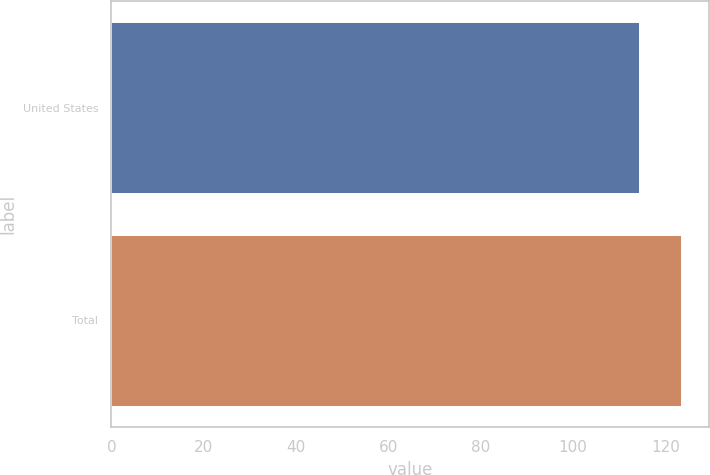Convert chart. <chart><loc_0><loc_0><loc_500><loc_500><bar_chart><fcel>United States<fcel>Total<nl><fcel>114.2<fcel>123.3<nl></chart> 